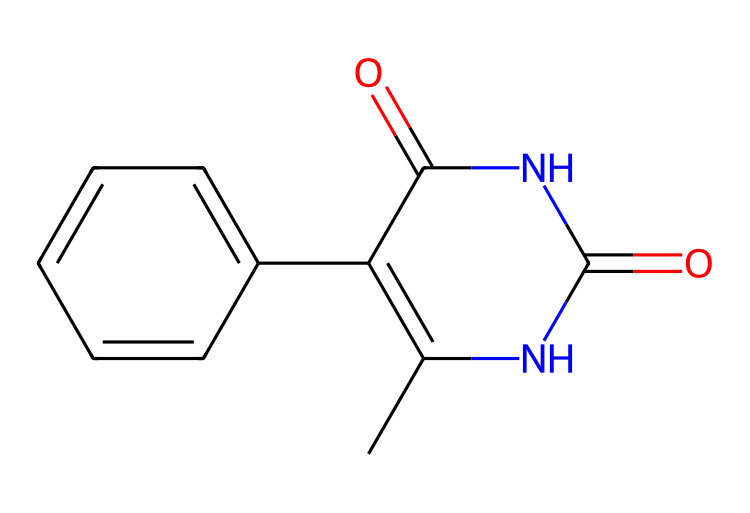What is the molecular formula of this compound? To find the molecular formula, we need to count the number of each type of atom represented in the SMILES. The SMILES indicates the presence of carbon (C), nitrogen (N), and oxygen (O) atoms. Counting them gives us C10, H10, N4, O2.
Answer: C10H10N4O2 How many rings are in the chemical structure? The structure shows two fused rings, which can be identified by examining the connections and the arrangement of the atoms. The presence of the nitrogen atoms is also typically indicative of ring structures in this context.
Answer: 2 Is this structure likely to be soluble in water? The presence of nitrogen and oxygen atoms suggests the potential for hydrogen bonding, which is generally associated with increased solubility in water. The overall structure being relatively compact with functional groups also supports this.
Answer: Yes What type of drug class does this compound belong to? By analyzing the structure, we can infer that this compound features amide bonds and is likely to be an antibiotic. The nitrogen functionality associated with antibiotic actions, such as inhibiting bacterial growth, supports this classification.
Answer: Antibiotic Does this compound have any chiral centers? A chiral center is typically a carbon atom connected to four different groups. In reviewing the structural layout of the atoms, we can identify whether there are any such carbon atoms. In this case, there appears to be one carbon connected to different substituents.
Answer: Yes 